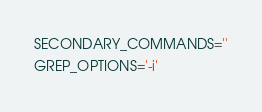Convert code to text. <code><loc_0><loc_0><loc_500><loc_500><_Bash_>SECONDARY_COMMANDS=''
GREP_OPTIONS='-i'</code> 